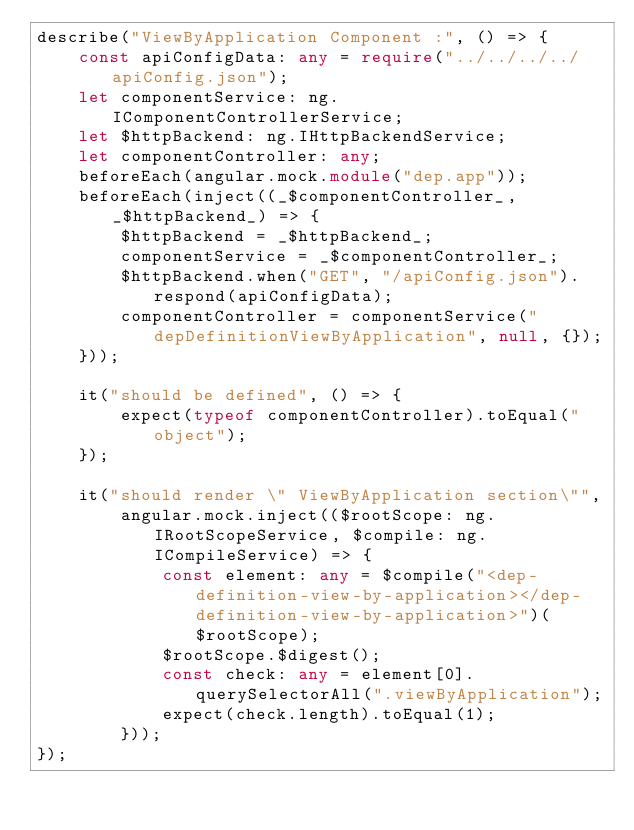Convert code to text. <code><loc_0><loc_0><loc_500><loc_500><_TypeScript_>describe("ViewByApplication Component :", () => {
    const apiConfigData: any = require("../../../../apiConfig.json");
    let componentService: ng.IComponentControllerService;
    let $httpBackend: ng.IHttpBackendService;
    let componentController: any;
    beforeEach(angular.mock.module("dep.app"));
    beforeEach(inject((_$componentController_, _$httpBackend_) => {
        $httpBackend = _$httpBackend_;
        componentService = _$componentController_;
        $httpBackend.when("GET", "/apiConfig.json").respond(apiConfigData);
        componentController = componentService("depDefinitionViewByApplication", null, {});
    }));

    it("should be defined", () => {
        expect(typeof componentController).toEqual("object");
    });

    it("should render \" ViewByApplication section\"",
        angular.mock.inject(($rootScope: ng.IRootScopeService, $compile: ng.ICompileService) => {
            const element: any = $compile("<dep-definition-view-by-application></dep-definition-view-by-application>")($rootScope);
            $rootScope.$digest();
            const check: any = element[0].querySelectorAll(".viewByApplication");
            expect(check.length).toEqual(1);
        }));
});</code> 